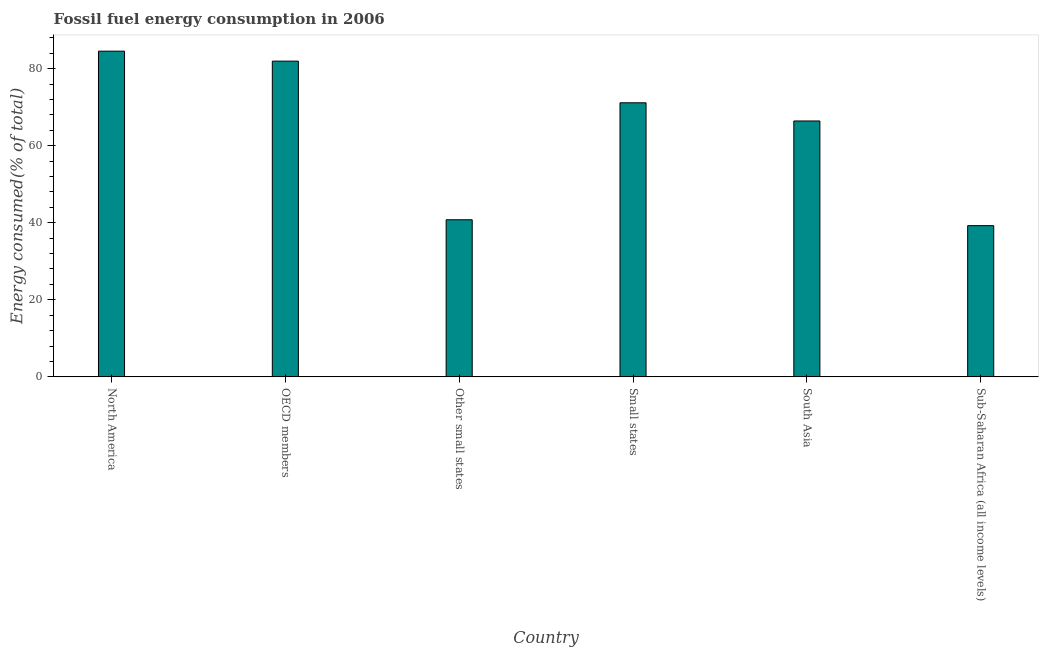What is the title of the graph?
Keep it short and to the point. Fossil fuel energy consumption in 2006. What is the label or title of the X-axis?
Make the answer very short. Country. What is the label or title of the Y-axis?
Give a very brief answer. Energy consumed(% of total). What is the fossil fuel energy consumption in Sub-Saharan Africa (all income levels)?
Make the answer very short. 39.25. Across all countries, what is the maximum fossil fuel energy consumption?
Your response must be concise. 84.53. Across all countries, what is the minimum fossil fuel energy consumption?
Your response must be concise. 39.25. In which country was the fossil fuel energy consumption maximum?
Offer a very short reply. North America. In which country was the fossil fuel energy consumption minimum?
Make the answer very short. Sub-Saharan Africa (all income levels). What is the sum of the fossil fuel energy consumption?
Keep it short and to the point. 384.04. What is the difference between the fossil fuel energy consumption in Small states and Sub-Saharan Africa (all income levels)?
Keep it short and to the point. 31.89. What is the average fossil fuel energy consumption per country?
Give a very brief answer. 64.01. What is the median fossil fuel energy consumption?
Your answer should be very brief. 68.77. What is the ratio of the fossil fuel energy consumption in Other small states to that in Small states?
Make the answer very short. 0.57. Is the fossil fuel energy consumption in OECD members less than that in South Asia?
Your answer should be compact. No. Is the difference between the fossil fuel energy consumption in North America and Sub-Saharan Africa (all income levels) greater than the difference between any two countries?
Give a very brief answer. Yes. What is the difference between the highest and the second highest fossil fuel energy consumption?
Your answer should be very brief. 2.59. Is the sum of the fossil fuel energy consumption in South Asia and Sub-Saharan Africa (all income levels) greater than the maximum fossil fuel energy consumption across all countries?
Provide a short and direct response. Yes. What is the difference between the highest and the lowest fossil fuel energy consumption?
Provide a succinct answer. 45.29. In how many countries, is the fossil fuel energy consumption greater than the average fossil fuel energy consumption taken over all countries?
Provide a short and direct response. 4. How many bars are there?
Give a very brief answer. 6. Are all the bars in the graph horizontal?
Keep it short and to the point. No. Are the values on the major ticks of Y-axis written in scientific E-notation?
Ensure brevity in your answer.  No. What is the Energy consumed(% of total) of North America?
Offer a very short reply. 84.53. What is the Energy consumed(% of total) in OECD members?
Your response must be concise. 81.94. What is the Energy consumed(% of total) in Other small states?
Give a very brief answer. 40.77. What is the Energy consumed(% of total) in Small states?
Offer a terse response. 71.13. What is the Energy consumed(% of total) in South Asia?
Your answer should be very brief. 66.41. What is the Energy consumed(% of total) of Sub-Saharan Africa (all income levels)?
Offer a very short reply. 39.25. What is the difference between the Energy consumed(% of total) in North America and OECD members?
Provide a short and direct response. 2.59. What is the difference between the Energy consumed(% of total) in North America and Other small states?
Provide a succinct answer. 43.76. What is the difference between the Energy consumed(% of total) in North America and Small states?
Make the answer very short. 13.4. What is the difference between the Energy consumed(% of total) in North America and South Asia?
Your answer should be compact. 18.12. What is the difference between the Energy consumed(% of total) in North America and Sub-Saharan Africa (all income levels)?
Offer a very short reply. 45.29. What is the difference between the Energy consumed(% of total) in OECD members and Other small states?
Provide a succinct answer. 41.17. What is the difference between the Energy consumed(% of total) in OECD members and Small states?
Your answer should be very brief. 10.81. What is the difference between the Energy consumed(% of total) in OECD members and South Asia?
Provide a succinct answer. 15.53. What is the difference between the Energy consumed(% of total) in OECD members and Sub-Saharan Africa (all income levels)?
Provide a short and direct response. 42.7. What is the difference between the Energy consumed(% of total) in Other small states and Small states?
Provide a succinct answer. -30.36. What is the difference between the Energy consumed(% of total) in Other small states and South Asia?
Your answer should be very brief. -25.64. What is the difference between the Energy consumed(% of total) in Other small states and Sub-Saharan Africa (all income levels)?
Offer a terse response. 1.53. What is the difference between the Energy consumed(% of total) in Small states and South Asia?
Your answer should be compact. 4.72. What is the difference between the Energy consumed(% of total) in Small states and Sub-Saharan Africa (all income levels)?
Your answer should be very brief. 31.89. What is the difference between the Energy consumed(% of total) in South Asia and Sub-Saharan Africa (all income levels)?
Your answer should be compact. 27.17. What is the ratio of the Energy consumed(% of total) in North America to that in OECD members?
Provide a short and direct response. 1.03. What is the ratio of the Energy consumed(% of total) in North America to that in Other small states?
Your answer should be compact. 2.07. What is the ratio of the Energy consumed(% of total) in North America to that in Small states?
Your answer should be very brief. 1.19. What is the ratio of the Energy consumed(% of total) in North America to that in South Asia?
Offer a terse response. 1.27. What is the ratio of the Energy consumed(% of total) in North America to that in Sub-Saharan Africa (all income levels)?
Give a very brief answer. 2.15. What is the ratio of the Energy consumed(% of total) in OECD members to that in Other small states?
Ensure brevity in your answer.  2.01. What is the ratio of the Energy consumed(% of total) in OECD members to that in Small states?
Your response must be concise. 1.15. What is the ratio of the Energy consumed(% of total) in OECD members to that in South Asia?
Ensure brevity in your answer.  1.23. What is the ratio of the Energy consumed(% of total) in OECD members to that in Sub-Saharan Africa (all income levels)?
Give a very brief answer. 2.09. What is the ratio of the Energy consumed(% of total) in Other small states to that in Small states?
Provide a succinct answer. 0.57. What is the ratio of the Energy consumed(% of total) in Other small states to that in South Asia?
Your response must be concise. 0.61. What is the ratio of the Energy consumed(% of total) in Other small states to that in Sub-Saharan Africa (all income levels)?
Make the answer very short. 1.04. What is the ratio of the Energy consumed(% of total) in Small states to that in South Asia?
Make the answer very short. 1.07. What is the ratio of the Energy consumed(% of total) in Small states to that in Sub-Saharan Africa (all income levels)?
Offer a terse response. 1.81. What is the ratio of the Energy consumed(% of total) in South Asia to that in Sub-Saharan Africa (all income levels)?
Provide a short and direct response. 1.69. 